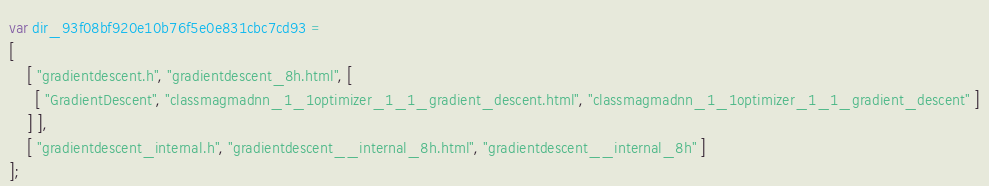Convert code to text. <code><loc_0><loc_0><loc_500><loc_500><_JavaScript_>var dir_93f08bf920e10b76f5e0e831cbc7cd93 =
[
    [ "gradientdescent.h", "gradientdescent_8h.html", [
      [ "GradientDescent", "classmagmadnn_1_1optimizer_1_1_gradient_descent.html", "classmagmadnn_1_1optimizer_1_1_gradient_descent" ]
    ] ],
    [ "gradientdescent_internal.h", "gradientdescent__internal_8h.html", "gradientdescent__internal_8h" ]
];</code> 